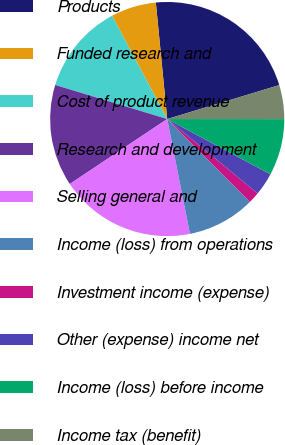Convert chart. <chart><loc_0><loc_0><loc_500><loc_500><pie_chart><fcel>Products<fcel>Funded research and<fcel>Cost of product revenue<fcel>Research and development<fcel>Selling general and<fcel>Income (loss) from operations<fcel>Investment income (expense)<fcel>Other (expense) income net<fcel>Income (loss) before income<fcel>Income tax (benefit)<nl><fcel>21.87%<fcel>6.25%<fcel>12.5%<fcel>14.06%<fcel>18.75%<fcel>9.38%<fcel>1.56%<fcel>3.13%<fcel>7.81%<fcel>4.69%<nl></chart> 